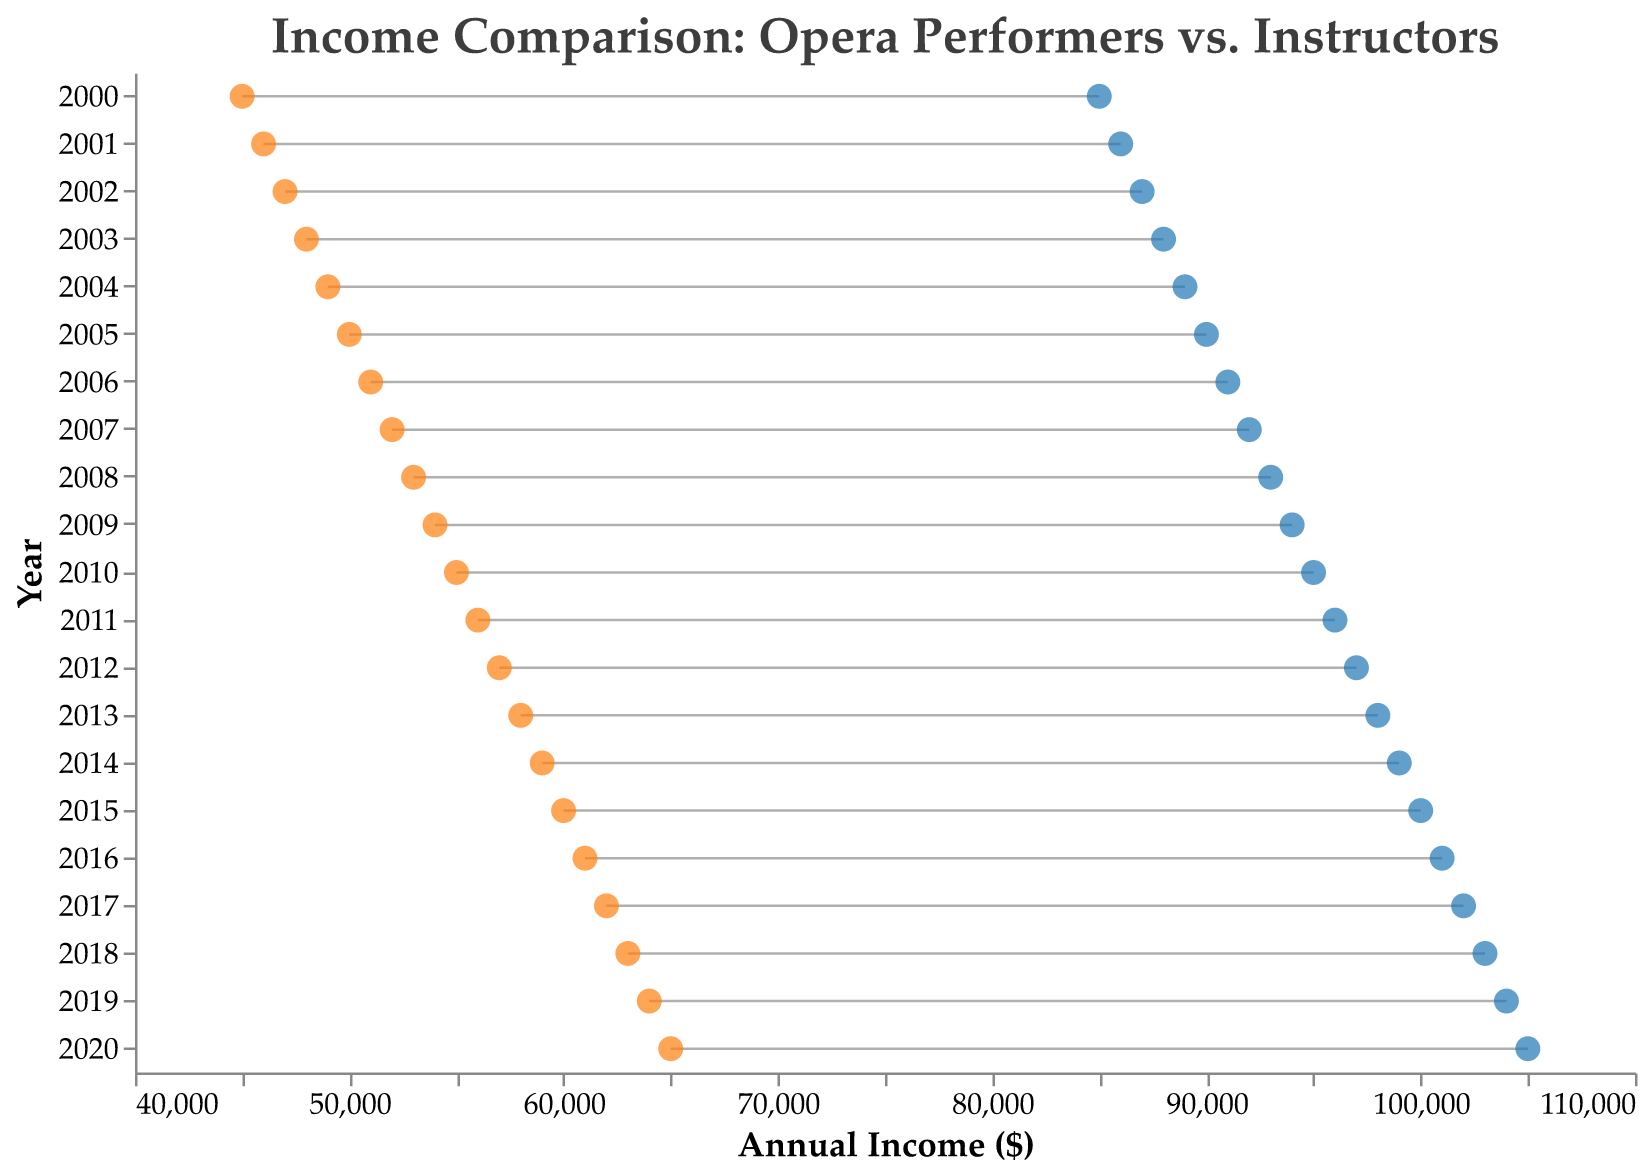What is the difference in income between a Professional Opera Performer and an Opera Instructor in the year 2000? To find the difference in income in the year 2000, subtract the Opera Instructor's income from the Professional Opera Performer's income for that year. The values are $85,000 and $45,000 respectively, so $85,000 - $45,000 = $40,000.
Answer: $40,000 What is the average income of a Professional Opera Performer from 2000 to 2020? To find the average income, add up all the Professional Opera Performers' incomes from 2000 to 2020 and then divide by the number of years (21). The sum is $85000+$86000+$87000+$88000+$89000+$90000+$91000+$92000+$93000+$94000+$95000+$96000+$97000+$98000+$99000+$100000+$101000+$102000+$103000+$104000+$105000 = $2,030,000. The average is $2,030,000 / 21 = $96,666.67.
Answer: $96,666.67 How much did the income of Opera Instructors increase from 2000 to 2020? To find the increase, subtract the income of Opera Instructors in 2000 from their income in 2020. The values are $45,000 and $65,000 respectively, so $65,000 - $45,000 = $20,000.
Answer: $20,000 In which year was the difference between the incomes of Professional Opera Performers and Opera Instructors the smallest? By examining the Dumbbell Plot, look for the year where the gap (the horizontal line) between the two points is the shortest. It is the smallest in the year 2020, where the difference is $40,000.
Answer: 2020 What is the trend of incomes for both Professional Opera Performers and Opera Instructors over the years? The trend for both is a steady increase over time. Each year, the incomes of both Professional Opera Performers and Opera Instructors increase incrementally.
Answer: Steady increase In which year did the Professional Opera Performers' income reach the six-figure mark? Look for the year where the income of Professional Opera Performers first reaches or exceeds $100,000. In the Dumbbell Plot, this occurs in the year 2015.
Answer: 2015 Are there any years where the incomes of both Professional Opera Performers and Opera Instructors are the same? By examining the Dumbbell Plot, look for any overlapping points between the two incomes. There are no years where the incomes of both are the same, as each year shows a visible gap between the two incomes.
Answer: No What is the range of income for Opera Instructors over the 21 years? To find the range, subtract the lowest income from the highest income of Opera Instructors over the period. From the plot, the lowest is $45,000 in 2000 and the highest is $65,000 in 2020. The range is $65,000 - $45,000 = $20,000.
Answer: $20,000 What is the approximate annual growth rate of Professional Opera Performers' income from 2000 to 2020? Calculate the annual growth rate using the formula: [(Final Value / Initial Value)^(1/Number of Years)] - 1. For Professional Opera Performers, Final Value is $105,000, Initial Value is $85,000, and Number of Years is 20. The annual growth rate is [(105,000 / 85,000)^(1/20)] - 1 ≈ 0.011 or 1.1%.
Answer: 1.1% What significant observation can be made by comparing the income trends of the two groups? By comparing the Dumbbell Plot, notice that Professional Opera Performers consistently earn more than Opera Instructors, and while both incomes grow, the gap remains relatively constant, indicating a persistent income disparity.
Answer: Persistent income disparity 